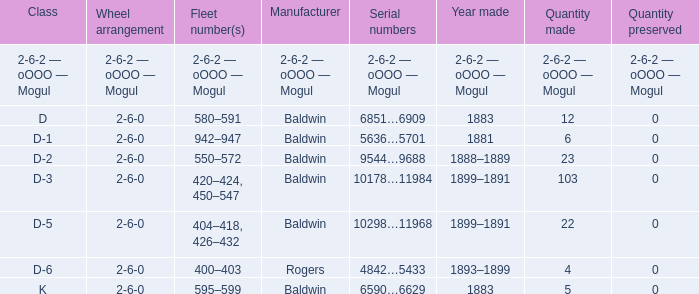What is the class when the quantity perserved is 0 and the quantity made is 5? K. 